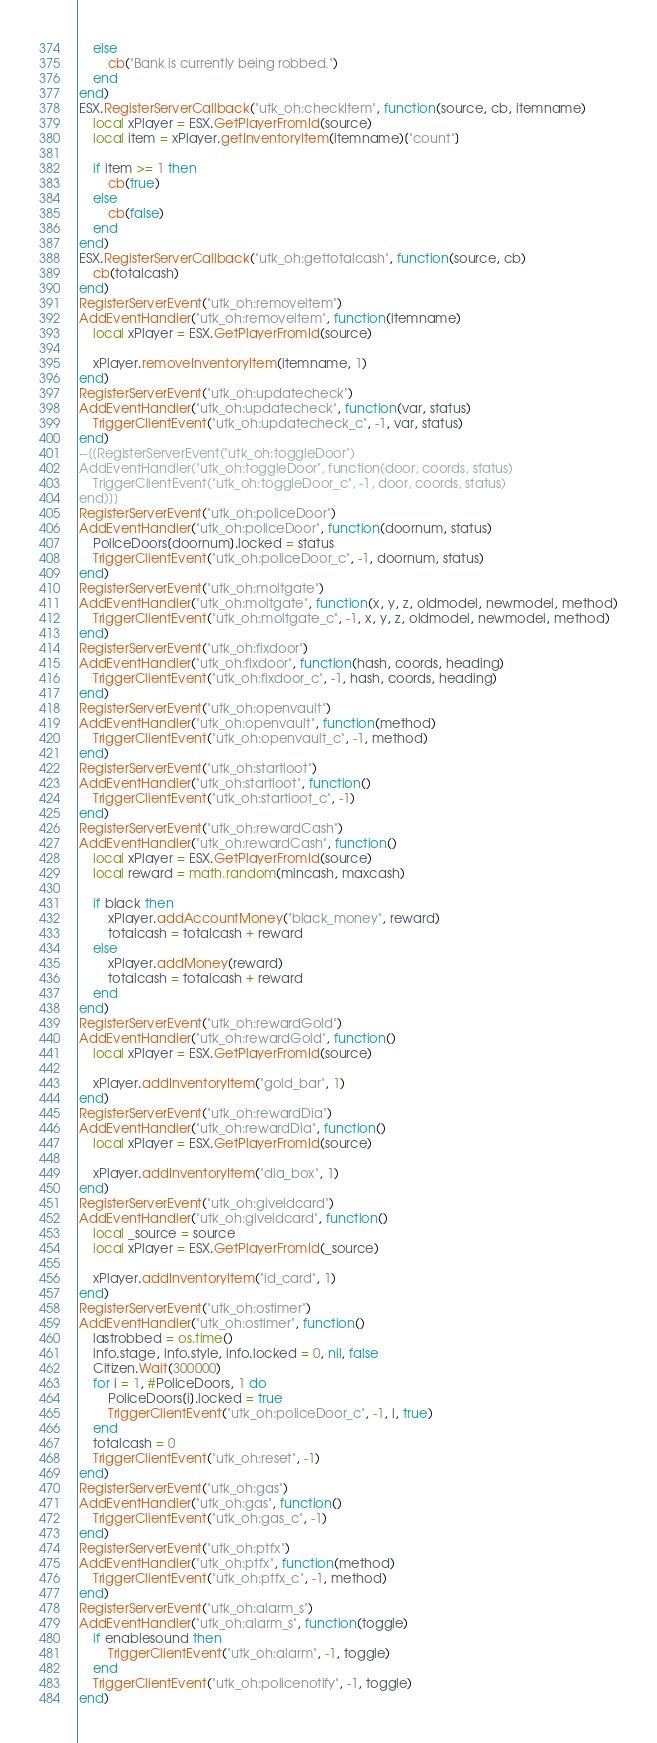Convert code to text. <code><loc_0><loc_0><loc_500><loc_500><_Lua_>    else
        cb("Bank is currently being robbed.")
    end
end)
ESX.RegisterServerCallback("utk_oh:checkItem", function(source, cb, itemname)
    local xPlayer = ESX.GetPlayerFromId(source)
    local item = xPlayer.getInventoryItem(itemname)["count"]

    if item >= 1 then
        cb(true)
    else
        cb(false)
    end
end)
ESX.RegisterServerCallback("utk_oh:gettotalcash", function(source, cb)
    cb(totalcash)
end)
RegisterServerEvent("utk_oh:removeitem")
AddEventHandler("utk_oh:removeitem", function(itemname)
    local xPlayer = ESX.GetPlayerFromId(source)

    xPlayer.removeInventoryItem(itemname, 1)
end)
RegisterServerEvent("utk_oh:updatecheck")
AddEventHandler("utk_oh:updatecheck", function(var, status)
    TriggerClientEvent("utk_oh:updatecheck_c", -1, var, status)
end)
--[[RegisterServerEvent("utk_oh:toggleDoor")
AddEventHandler("utk_oh:toggleDoor", function(door, coords, status)
    TriggerClientEvent("utk_oh:toggleDoor_c", -1, door, coords, status)
end)]]
RegisterServerEvent("utk_oh:policeDoor")
AddEventHandler("utk_oh:policeDoor", function(doornum, status)
    PoliceDoors[doornum].locked = status
    TriggerClientEvent("utk_oh:policeDoor_c", -1, doornum, status)
end)
RegisterServerEvent("utk_oh:moltgate")
AddEventHandler("utk_oh:moltgate", function(x, y, z, oldmodel, newmodel, method)
    TriggerClientEvent("utk_oh:moltgate_c", -1, x, y, z, oldmodel, newmodel, method)
end)
RegisterServerEvent("utk_oh:fixdoor")
AddEventHandler("utk_oh:fixdoor", function(hash, coords, heading)
    TriggerClientEvent("utk_oh:fixdoor_c", -1, hash, coords, heading)
end)
RegisterServerEvent("utk_oh:openvault")
AddEventHandler("utk_oh:openvault", function(method)
    TriggerClientEvent("utk_oh:openvault_c", -1, method)
end)
RegisterServerEvent("utk_oh:startloot")
AddEventHandler("utk_oh:startloot", function()
    TriggerClientEvent("utk_oh:startloot_c", -1)
end)
RegisterServerEvent("utk_oh:rewardCash")
AddEventHandler("utk_oh:rewardCash", function()
    local xPlayer = ESX.GetPlayerFromId(source)
    local reward = math.random(mincash, maxcash)

    if black then
        xPlayer.addAccountMoney("black_money", reward)
        totalcash = totalcash + reward
    else
        xPlayer.addMoney(reward)
        totalcash = totalcash + reward
    end
end)
RegisterServerEvent("utk_oh:rewardGold")
AddEventHandler("utk_oh:rewardGold", function()
    local xPlayer = ESX.GetPlayerFromId(source)

    xPlayer.addInventoryItem("gold_bar", 1)
end)
RegisterServerEvent("utk_oh:rewardDia")
AddEventHandler("utk_oh:rewardDia", function()
    local xPlayer = ESX.GetPlayerFromId(source)

    xPlayer.addInventoryItem("dia_box", 1)
end)
RegisterServerEvent("utk_oh:giveidcard")
AddEventHandler("utk_oh:giveidcard", function()
    local _source = source
    local xPlayer = ESX.GetPlayerFromId(_source)

    xPlayer.addInventoryItem("id_card", 1)
end)
RegisterServerEvent("utk_oh:ostimer")
AddEventHandler("utk_oh:ostimer", function()
    lastrobbed = os.time()
    info.stage, info.style, info.locked = 0, nil, false
    Citizen.Wait(300000)
    for i = 1, #PoliceDoors, 1 do
        PoliceDoors[i].locked = true
        TriggerClientEvent("utk_oh:policeDoor_c", -1, i, true)
    end
    totalcash = 0
    TriggerClientEvent("utk_oh:reset", -1)
end)
RegisterServerEvent("utk_oh:gas")
AddEventHandler("utk_oh:gas", function()
    TriggerClientEvent("utk_oh:gas_c", -1)
end)
RegisterServerEvent("utk_oh:ptfx")
AddEventHandler("utk_oh:ptfx", function(method)
    TriggerClientEvent("utk_oh:ptfx_c", -1, method)
end)
RegisterServerEvent("utk_oh:alarm_s")
AddEventHandler("utk_oh:alarm_s", function(toggle)
    if enablesound then
        TriggerClientEvent("utk_oh:alarm", -1, toggle)
    end
    TriggerClientEvent("utk_oh:policenotify", -1, toggle)
end)
</code> 